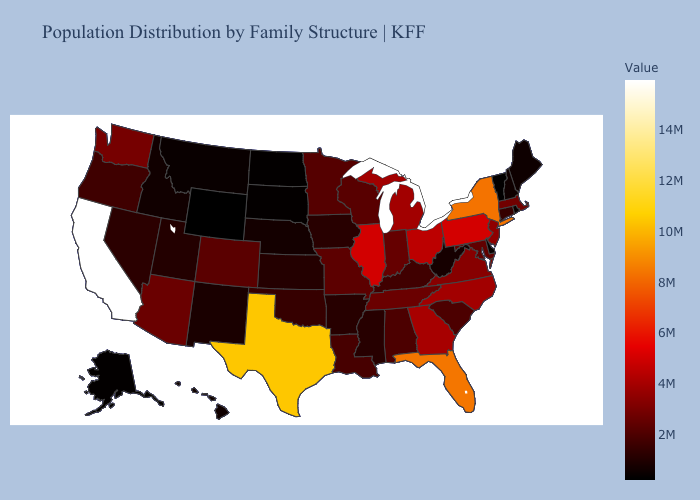Which states hav the highest value in the Northeast?
Answer briefly. New York. Does Illinois have a lower value than Washington?
Write a very short answer. No. Among the states that border Minnesota , which have the highest value?
Concise answer only. Wisconsin. Does Maryland have the lowest value in the USA?
Keep it brief. No. Which states hav the highest value in the MidWest?
Quick response, please. Illinois. Does Oklahoma have the highest value in the USA?
Concise answer only. No. Does Virginia have a higher value than Mississippi?
Answer briefly. Yes. Is the legend a continuous bar?
Be succinct. Yes. Does the map have missing data?
Answer briefly. No. 